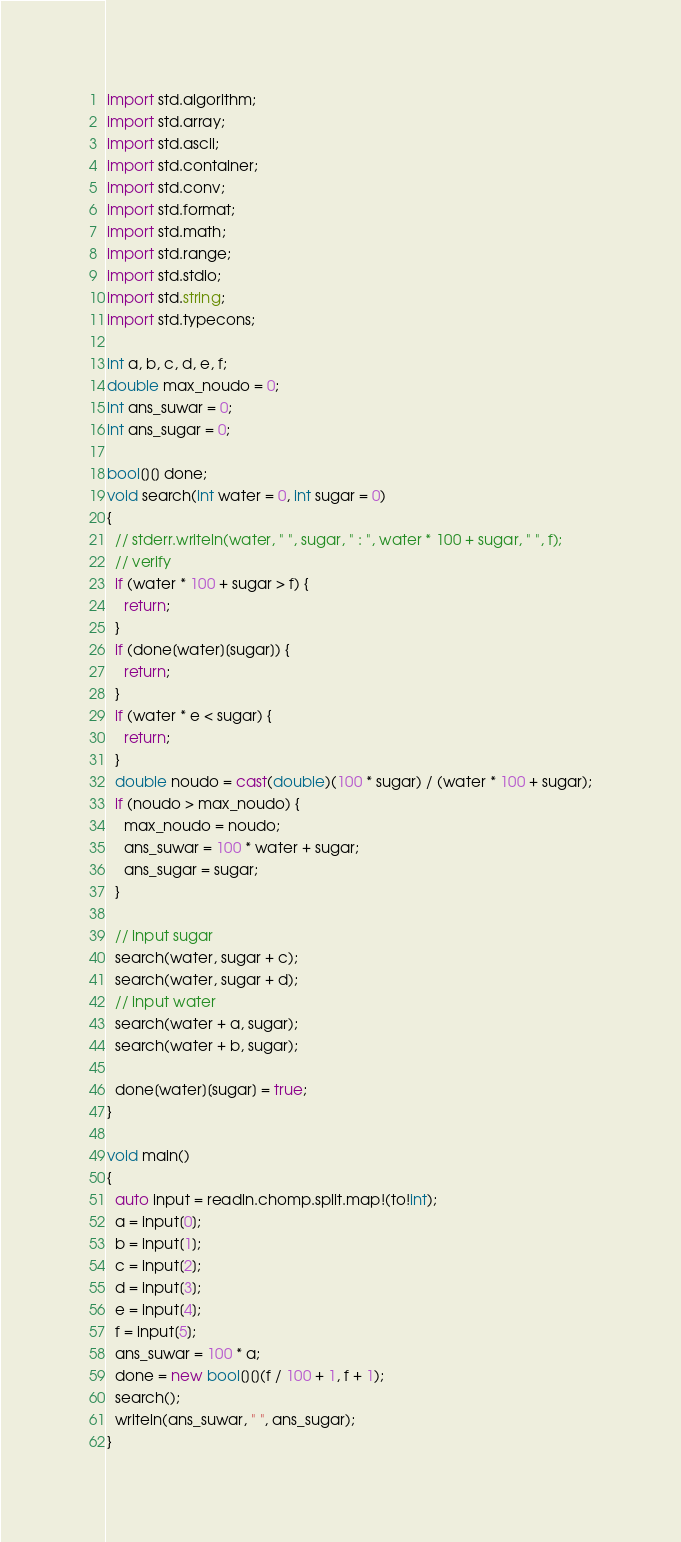Convert code to text. <code><loc_0><loc_0><loc_500><loc_500><_D_>import std.algorithm;
import std.array;
import std.ascii;
import std.container;
import std.conv;
import std.format;
import std.math;
import std.range;
import std.stdio;
import std.string;
import std.typecons;

int a, b, c, d, e, f;
double max_noudo = 0;
int ans_suwar = 0;
int ans_sugar = 0;

bool[][] done;
void search(int water = 0, int sugar = 0)
{
  // stderr.writeln(water, " ", sugar, " : ", water * 100 + sugar, " ", f);
  // verify
  if (water * 100 + sugar > f) {
    return;
  }
  if (done[water][sugar]) {
    return;
  }
  if (water * e < sugar) {
    return;
  }
  double noudo = cast(double)(100 * sugar) / (water * 100 + sugar);
  if (noudo > max_noudo) {
    max_noudo = noudo;
    ans_suwar = 100 * water + sugar;
    ans_sugar = sugar;
  }

  // input sugar
  search(water, sugar + c);
  search(water, sugar + d);
  // input water
  search(water + a, sugar);
  search(water + b, sugar);

  done[water][sugar] = true;
}

void main()
{
  auto input = readln.chomp.split.map!(to!int);
  a = input[0];
  b = input[1];
  c = input[2];
  d = input[3];
  e = input[4];
  f = input[5];
  ans_suwar = 100 * a;
  done = new bool[][](f / 100 + 1, f + 1);
  search();
  writeln(ans_suwar, " ", ans_sugar);
}
</code> 